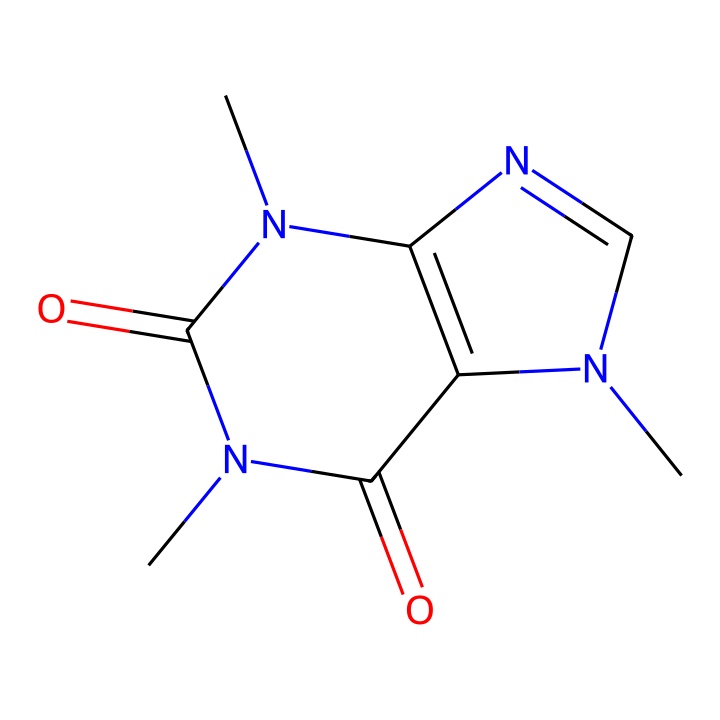What is the molecular formula of caffeine? The molecular formula can be derived from the structure by counting the types and numbers of atoms present in the SMILES representation. In this case, the count reveals 8 carbon (C) atoms, 10 hydrogen (H) atoms, 4 nitrogen (N) atoms, and 2 oxygen (O) atoms, leading to the formula C8H10N4O2.
Answer: C8H10N4O2 How many nitrogen atoms are in caffeine? By analyzing the SMILES representation, I can identify the nitrogen atoms. The structure shows there are four distinct nitrogen atoms in the arrangement.
Answer: 4 What type of compound is caffeine? Caffeine is classified as an alkaloid, which are organic compounds that contain nitrogen and usually have pronounced physiological effects. The presence of nitrogen atoms supports this classification.
Answer: alkaloid What are the functional groups present in caffeine? Reviewing the chemical structure shows there are amine and carbonyl functional groups present. The nitrogen atoms imply amine groups, and the carbonyls are inferred from the double bonds with oxygen.
Answer: amine and carbonyl What is the primary physiological effect of caffeine? Caffeine is well-known for its stimulant effect, primarily due to its action on the central nervous system, providing increased alertness. This effect is linked to its structural properties as an alkaloid.
Answer: stimulant 